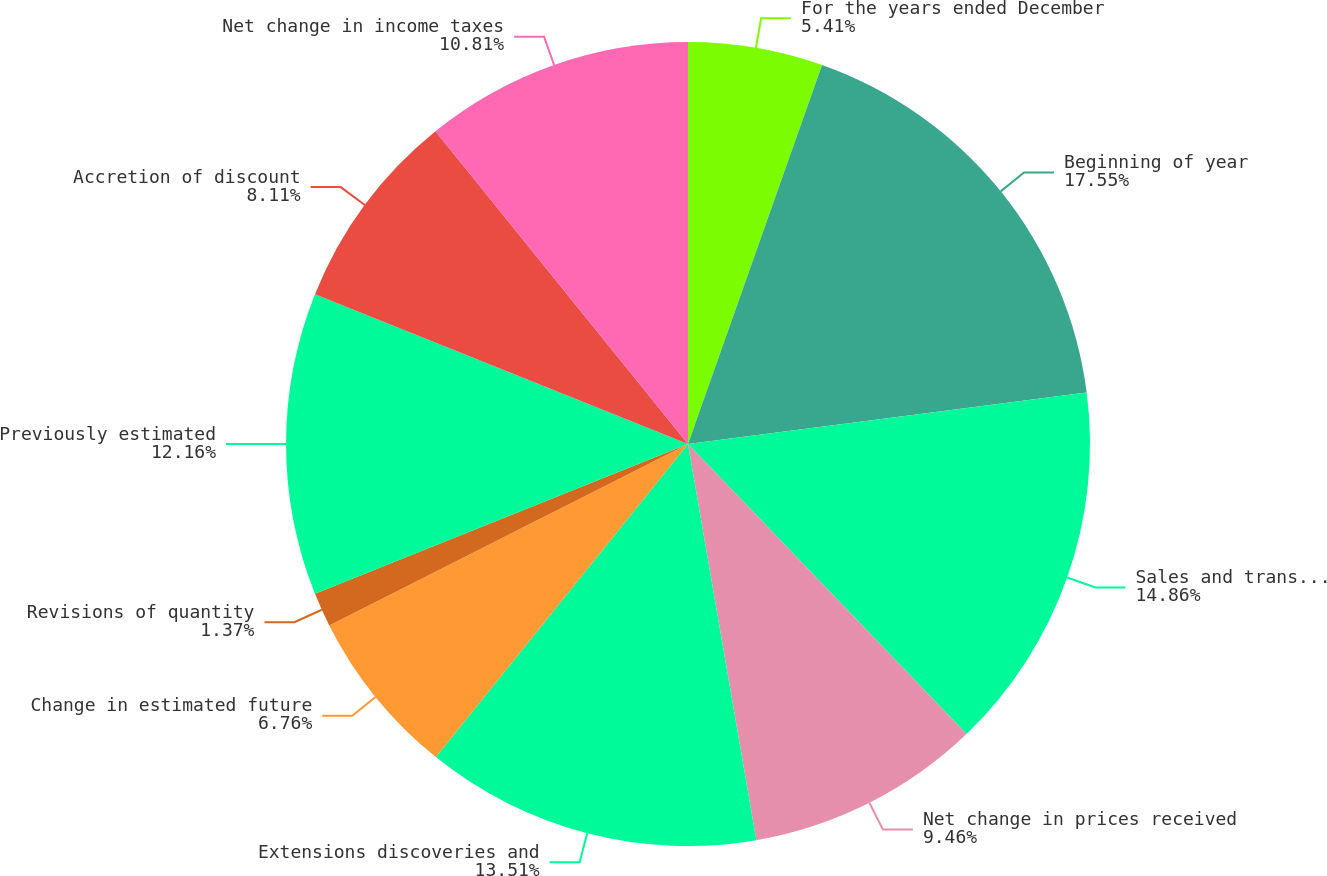Convert chart. <chart><loc_0><loc_0><loc_500><loc_500><pie_chart><fcel>For the years ended December<fcel>Beginning of year<fcel>Sales and transfers of oil and<fcel>Net change in prices received<fcel>Extensions discoveries and<fcel>Change in estimated future<fcel>Revisions of quantity<fcel>Previously estimated<fcel>Accretion of discount<fcel>Net change in income taxes<nl><fcel>5.41%<fcel>17.55%<fcel>14.86%<fcel>9.46%<fcel>13.51%<fcel>6.76%<fcel>1.37%<fcel>12.16%<fcel>8.11%<fcel>10.81%<nl></chart> 